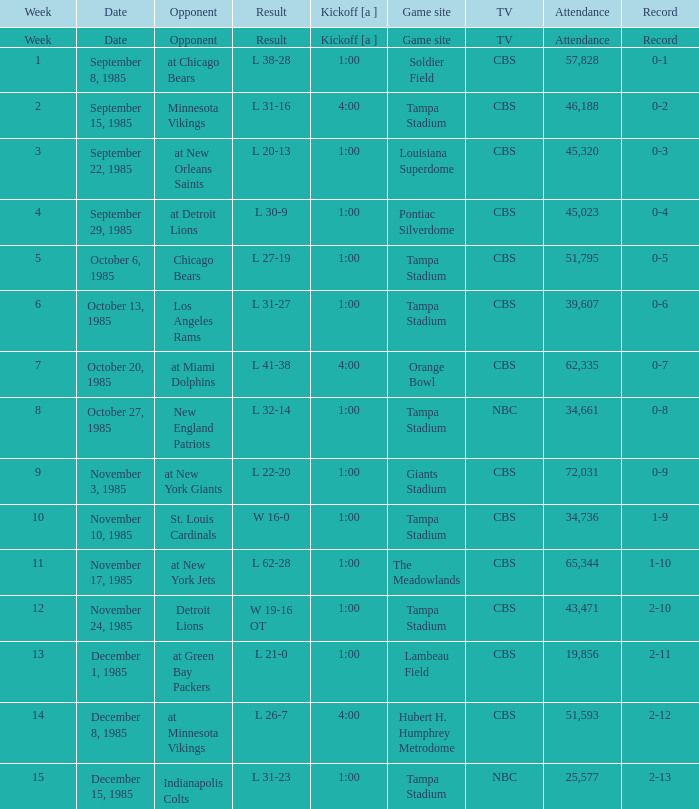Find all the result(s) with the record of 2-13. L 31-23. 